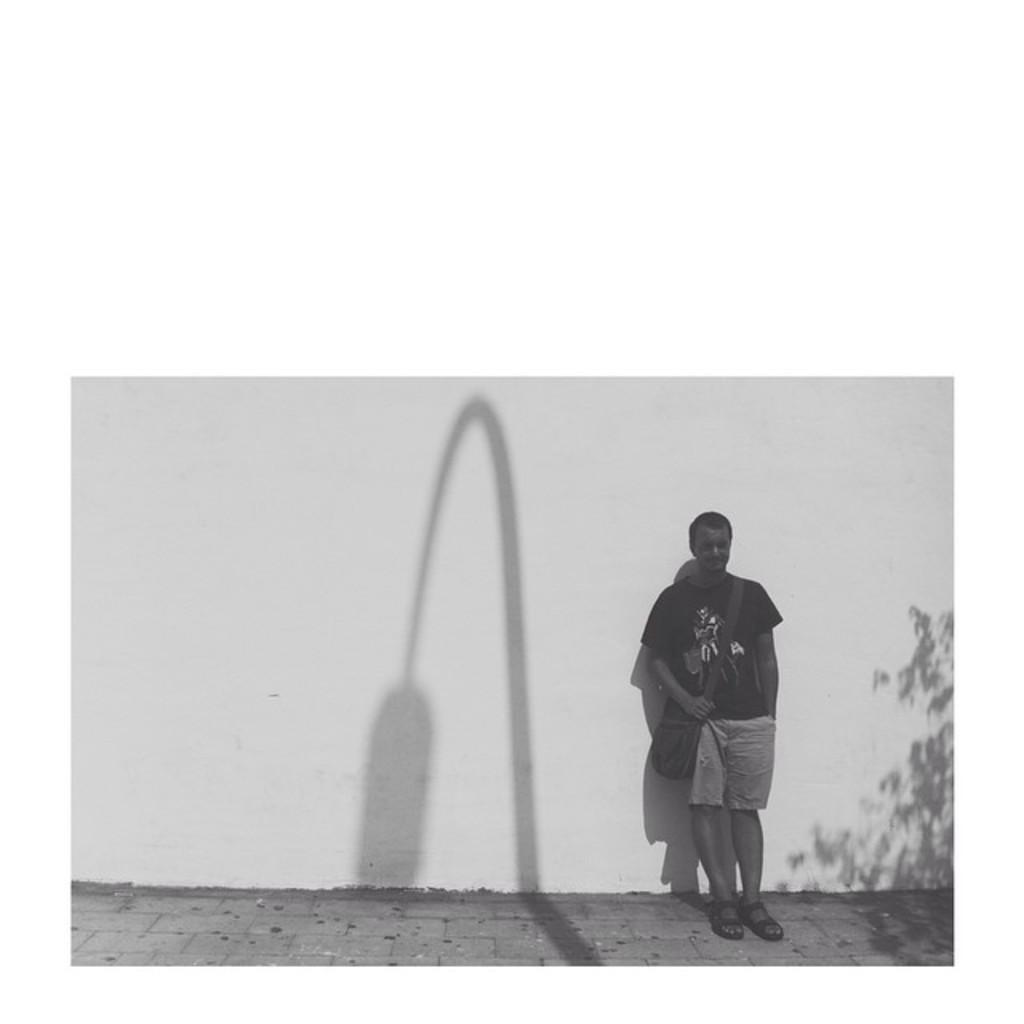How would you summarize this image in a sentence or two? In this image, we can see a man standing and he is carrying a bag, there is a white color wall. 